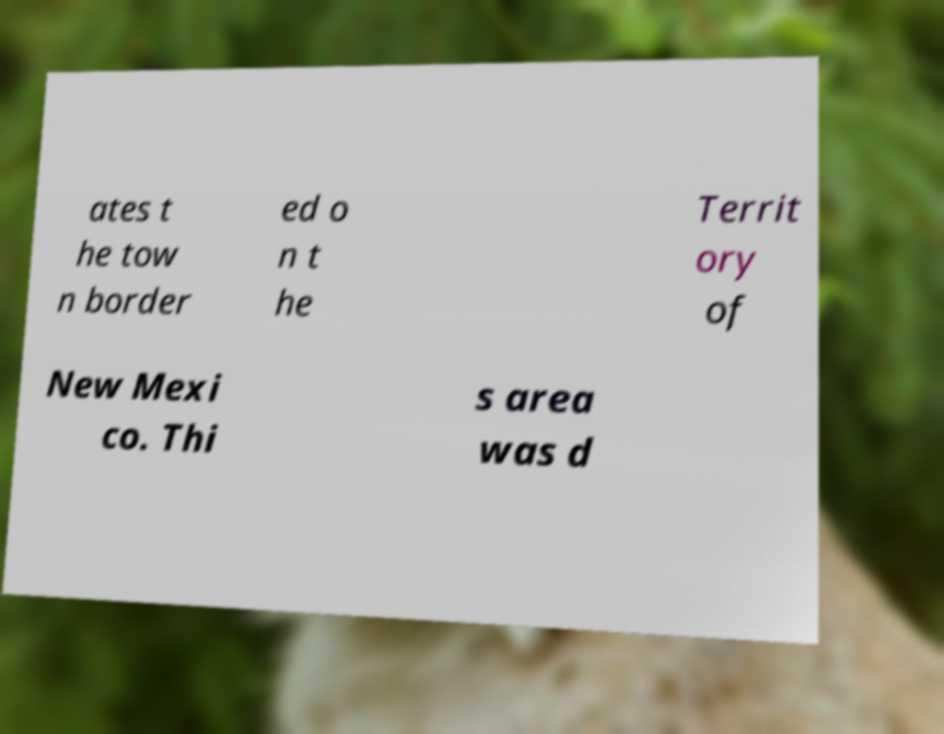Please identify and transcribe the text found in this image. ates t he tow n border ed o n t he Territ ory of New Mexi co. Thi s area was d 